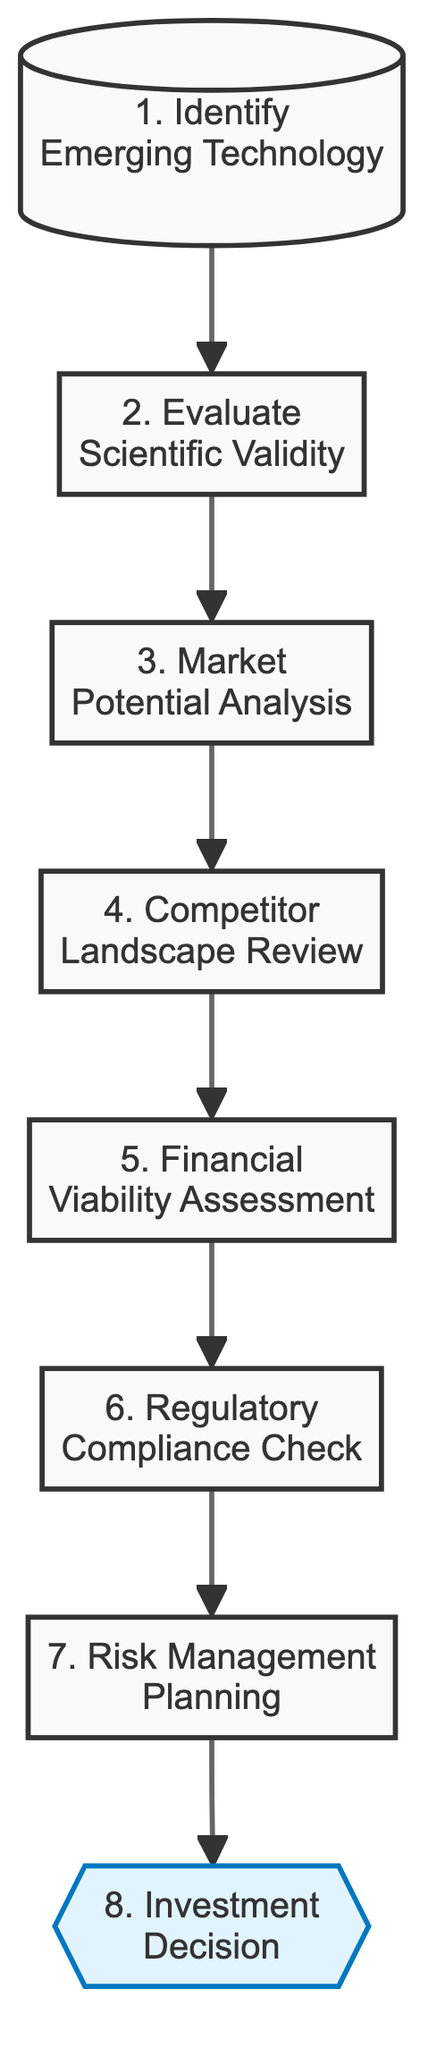What's the first step in the flowchart? The first step, as indicated in the diagram, is "Identify Emerging Technology," which means evaluating scientific research publications to spot potential emerging technologies.
Answer: Identify Emerging Technology How many steps are in the flowchart? By counting the elements presented in the diagram, there are a total of 8 steps in the flowchart that lead to the investment decision.
Answer: 8 What is the final decision based on? The final decision in the flowchart is based on "Investment Decision," which is informed by the comprehensive risk assessment and potential returns from all previous evaluations.
Answer: Investment Decision Which step follows “Market Potential Analysis”? In the flowchart, the step that follows "Market Potential Analysis" is "Competitor Landscape Review," which involves analyzing existing and potential competitors along with their technological advantages.
Answer: Competitor Landscape Review What is the focus of the "Risk Management Planning" step? The focus of the "Risk Management Planning" step is to create a risk matrix that identifies, assesses, and prioritizes risks related to the investment based on the earlier evaluations of the emerging technology.
Answer: Create a risk matrix Which step assesses the credibility of research findings? The step that assesses the credibility and reproducibility of research findings through peer-reviewed journals is "Evaluate Scientific Validity," occurring right after the first step in the flowchart.
Answer: Evaluate Scientific Validity What is examined in the "Regulatory Compliance Check"? The "Regulatory Compliance Check" examines the regulatory hurdles and requirements associated with deploying the technology, ensuring that the investment complies with necessary regulations.
Answer: Regulatory hurdles What precedes the "Financial Viability Assessment"? The step that precedes "Financial Viability Assessment" in the flowchart is "Competitor Landscape Review." This indicates that understanding competitors is essential before evaluating financial returns.
Answer: Competitor Landscape Review What is required to make an informed "Investment Decision"? To make an informed "Investment Decision," it requires a comprehensive risk assessment and an evaluation of potential returns learned from previous steps in the flowchart.
Answer: Comprehensive risk assessment 